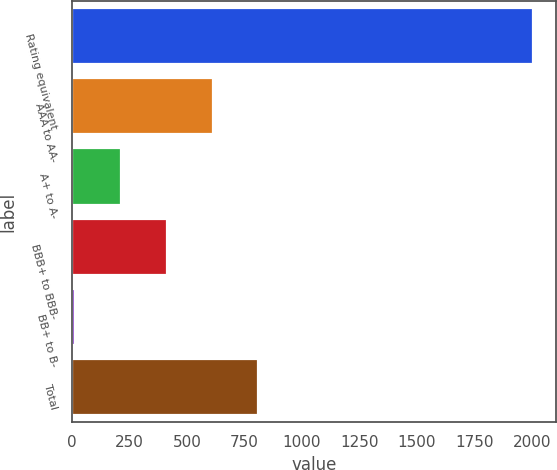Convert chart to OTSL. <chart><loc_0><loc_0><loc_500><loc_500><bar_chart><fcel>Rating equivalent<fcel>AAA to AA-<fcel>A+ to A-<fcel>BBB+ to BBB-<fcel>BB+ to B-<fcel>Total<nl><fcel>2005<fcel>612<fcel>214<fcel>413<fcel>15<fcel>811<nl></chart> 